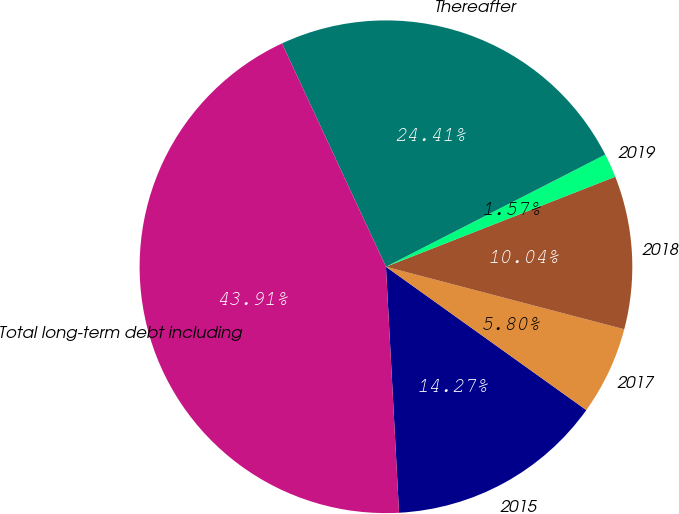Convert chart. <chart><loc_0><loc_0><loc_500><loc_500><pie_chart><fcel>2015<fcel>2017<fcel>2018<fcel>2019<fcel>Thereafter<fcel>Total long-term debt including<nl><fcel>14.27%<fcel>5.8%<fcel>10.04%<fcel>1.57%<fcel>24.41%<fcel>43.91%<nl></chart> 